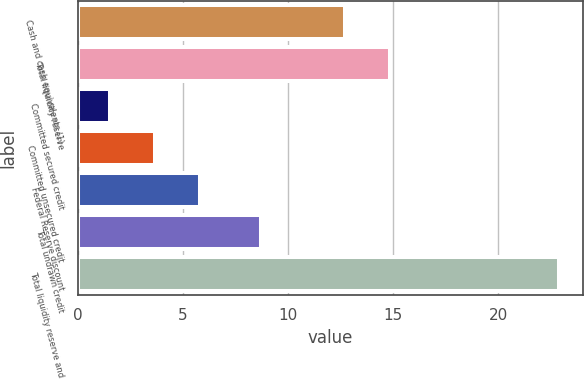Convert chart. <chart><loc_0><loc_0><loc_500><loc_500><bar_chart><fcel>Cash and cash equivalents (1)<fcel>Total liquidity reserve<fcel>Committed secured credit<fcel>Committed unsecured credit<fcel>Federal Reserve discount<fcel>Total undrawn credit<fcel>Total liquidity reserve and<nl><fcel>12.7<fcel>14.84<fcel>1.5<fcel>3.64<fcel>5.78<fcel>8.7<fcel>22.9<nl></chart> 